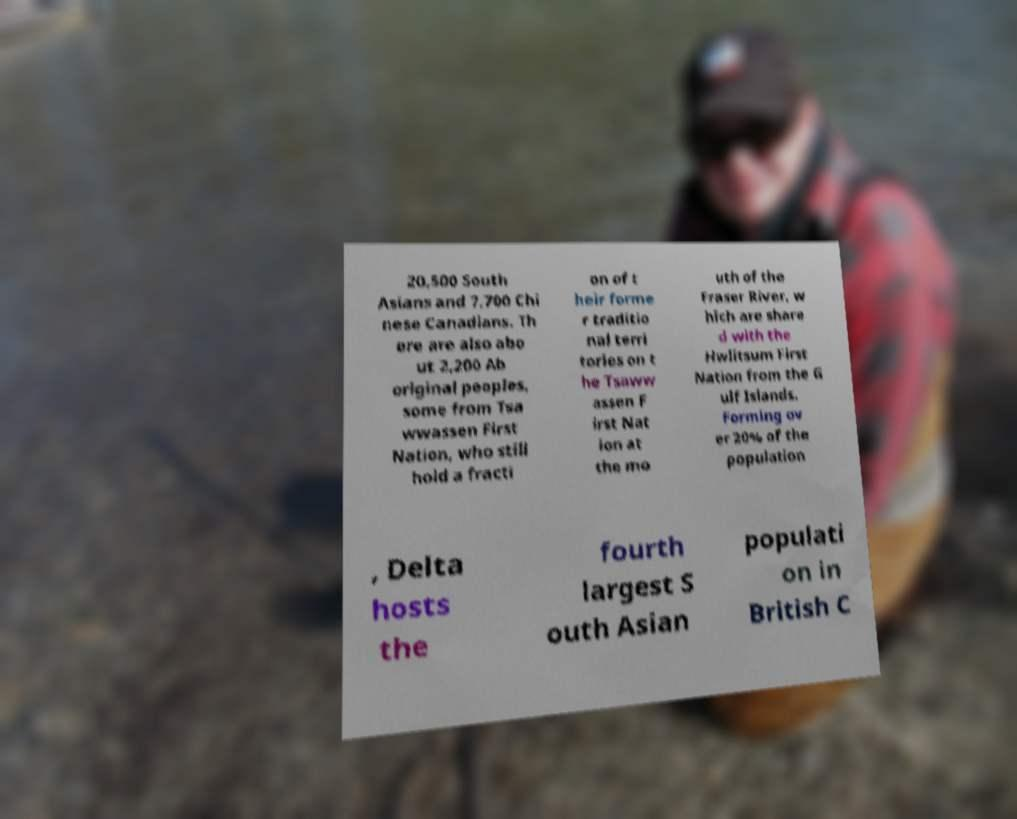Could you extract and type out the text from this image? 20,500 South Asians and 7,700 Chi nese Canadians. Th ere are also abo ut 2,200 Ab original peoples, some from Tsa wwassen First Nation, who still hold a fracti on of t heir forme r traditio nal terri tories on t he Tsaww assen F irst Nat ion at the mo uth of the Fraser River, w hich are share d with the Hwlitsum First Nation from the G ulf Islands. Forming ov er 20% of the population , Delta hosts the fourth largest S outh Asian populati on in British C 